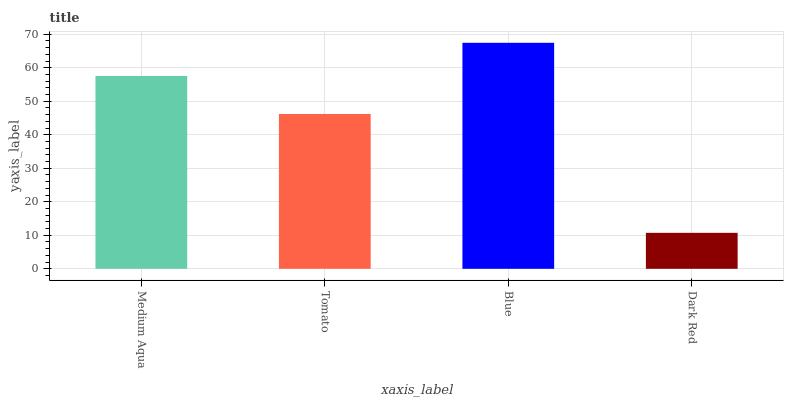Is Dark Red the minimum?
Answer yes or no. Yes. Is Blue the maximum?
Answer yes or no. Yes. Is Tomato the minimum?
Answer yes or no. No. Is Tomato the maximum?
Answer yes or no. No. Is Medium Aqua greater than Tomato?
Answer yes or no. Yes. Is Tomato less than Medium Aqua?
Answer yes or no. Yes. Is Tomato greater than Medium Aqua?
Answer yes or no. No. Is Medium Aqua less than Tomato?
Answer yes or no. No. Is Medium Aqua the high median?
Answer yes or no. Yes. Is Tomato the low median?
Answer yes or no. Yes. Is Tomato the high median?
Answer yes or no. No. Is Dark Red the low median?
Answer yes or no. No. 